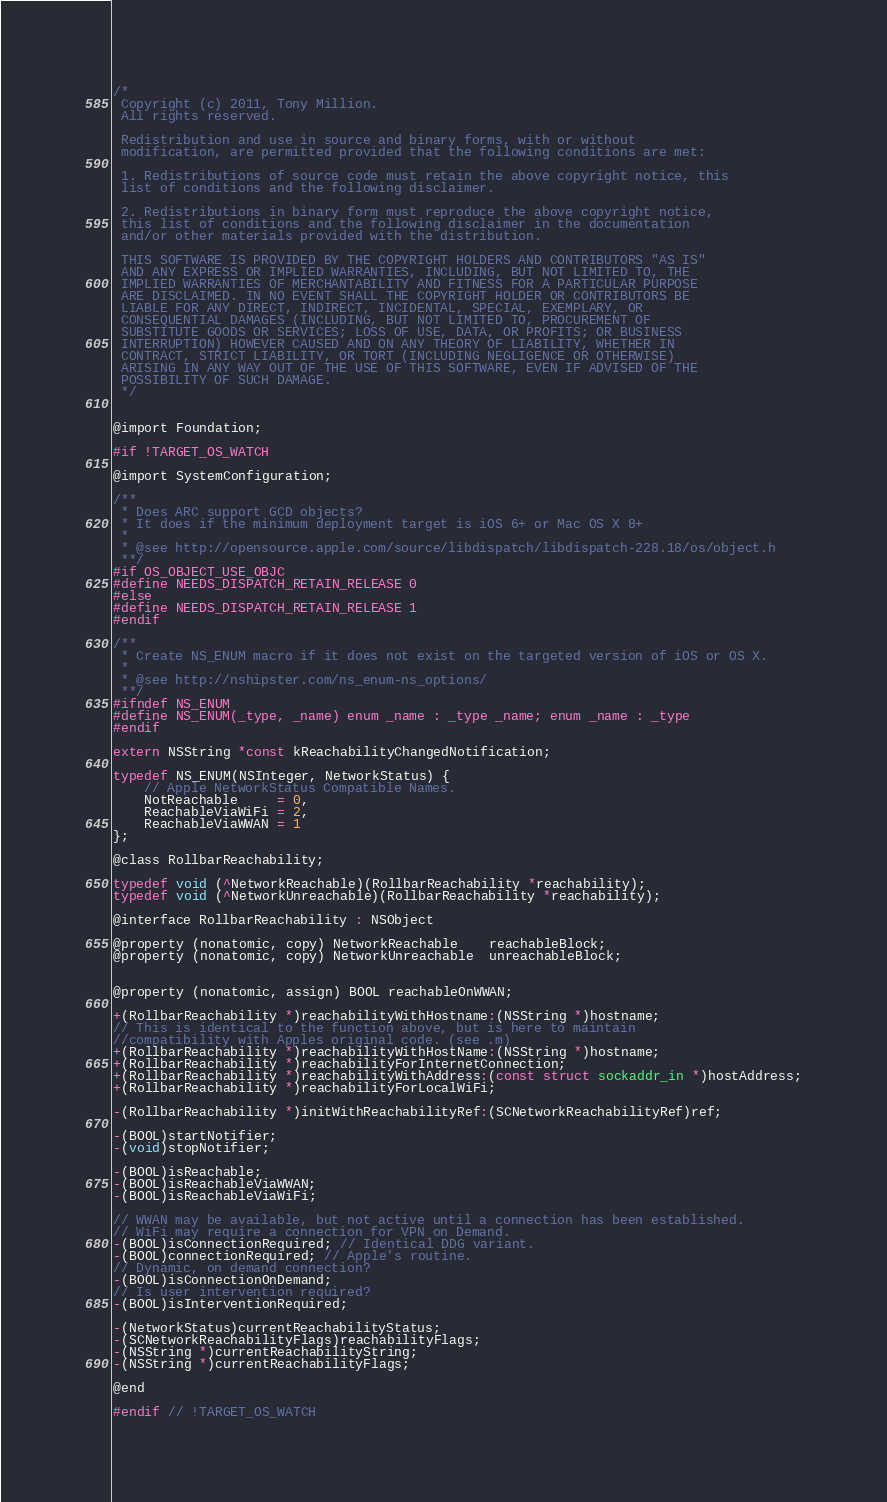Convert code to text. <code><loc_0><loc_0><loc_500><loc_500><_C_>/*
 Copyright (c) 2011, Tony Million.
 All rights reserved.
 
 Redistribution and use in source and binary forms, with or without
 modification, are permitted provided that the following conditions are met:
 
 1. Redistributions of source code must retain the above copyright notice, this
 list of conditions and the following disclaimer.
 
 2. Redistributions in binary form must reproduce the above copyright notice,
 this list of conditions and the following disclaimer in the documentation
 and/or other materials provided with the distribution.
 
 THIS SOFTWARE IS PROVIDED BY THE COPYRIGHT HOLDERS AND CONTRIBUTORS "AS IS"
 AND ANY EXPRESS OR IMPLIED WARRANTIES, INCLUDING, BUT NOT LIMITED TO, THE
 IMPLIED WARRANTIES OF MERCHANTABILITY AND FITNESS FOR A PARTICULAR PURPOSE
 ARE DISCLAIMED. IN NO EVENT SHALL THE COPYRIGHT HOLDER OR CONTRIBUTORS BE
 LIABLE FOR ANY DIRECT, INDIRECT, INCIDENTAL, SPECIAL, EXEMPLARY, OR
 CONSEQUENTIAL DAMAGES (INCLUDING, BUT NOT LIMITED TO, PROCUREMENT OF
 SUBSTITUTE GOODS OR SERVICES; LOSS OF USE, DATA, OR PROFITS; OR BUSINESS
 INTERRUPTION) HOWEVER CAUSED AND ON ANY THEORY OF LIABILITY, WHETHER IN
 CONTRACT, STRICT LIABILITY, OR TORT (INCLUDING NEGLIGENCE OR OTHERWISE)
 ARISING IN ANY WAY OUT OF THE USE OF THIS SOFTWARE, EVEN IF ADVISED OF THE
 POSSIBILITY OF SUCH DAMAGE.
 */


@import Foundation;

#if !TARGET_OS_WATCH

@import SystemConfiguration;

/**
 * Does ARC support GCD objects?
 * It does if the minimum deployment target is iOS 6+ or Mac OS X 8+
 *
 * @see http://opensource.apple.com/source/libdispatch/libdispatch-228.18/os/object.h
 **/
#if OS_OBJECT_USE_OBJC
#define NEEDS_DISPATCH_RETAIN_RELEASE 0
#else
#define NEEDS_DISPATCH_RETAIN_RELEASE 1
#endif

/**
 * Create NS_ENUM macro if it does not exist on the targeted version of iOS or OS X.
 *
 * @see http://nshipster.com/ns_enum-ns_options/
 **/
#ifndef NS_ENUM
#define NS_ENUM(_type, _name) enum _name : _type _name; enum _name : _type
#endif

extern NSString *const kReachabilityChangedNotification;

typedef NS_ENUM(NSInteger, NetworkStatus) {
    // Apple NetworkStatus Compatible Names.
    NotReachable     = 0,
    ReachableViaWiFi = 2,
    ReachableViaWWAN = 1
};

@class RollbarReachability;

typedef void (^NetworkReachable)(RollbarReachability *reachability);
typedef void (^NetworkUnreachable)(RollbarReachability *reachability);

@interface RollbarReachability : NSObject

@property (nonatomic, copy) NetworkReachable    reachableBlock;
@property (nonatomic, copy) NetworkUnreachable  unreachableBlock;


@property (nonatomic, assign) BOOL reachableOnWWAN;

+(RollbarReachability *)reachabilityWithHostname:(NSString *)hostname;
// This is identical to the function above, but is here to maintain
//compatibility with Apples original code. (see .m)
+(RollbarReachability *)reachabilityWithHostName:(NSString *)hostname;
+(RollbarReachability *)reachabilityForInternetConnection;
+(RollbarReachability *)reachabilityWithAddress:(const struct sockaddr_in *)hostAddress;
+(RollbarReachability *)reachabilityForLocalWiFi;

-(RollbarReachability *)initWithReachabilityRef:(SCNetworkReachabilityRef)ref;

-(BOOL)startNotifier;
-(void)stopNotifier;

-(BOOL)isReachable;
-(BOOL)isReachableViaWWAN;
-(BOOL)isReachableViaWiFi;

// WWAN may be available, but not active until a connection has been established.
// WiFi may require a connection for VPN on Demand.
-(BOOL)isConnectionRequired; // Identical DDG variant.
-(BOOL)connectionRequired; // Apple's routine.
// Dynamic, on demand connection?
-(BOOL)isConnectionOnDemand;
// Is user intervention required?
-(BOOL)isInterventionRequired;

-(NetworkStatus)currentReachabilityStatus;
-(SCNetworkReachabilityFlags)reachabilityFlags;
-(NSString *)currentReachabilityString;
-(NSString *)currentReachabilityFlags;

@end

#endif // !TARGET_OS_WATCH
</code> 